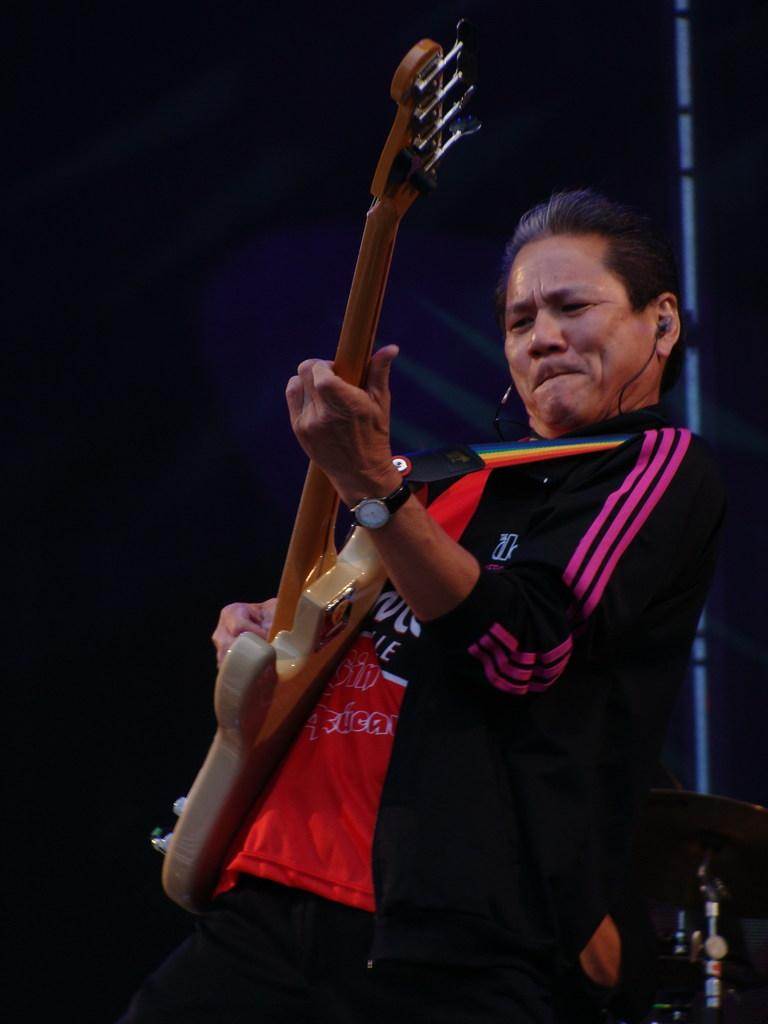What is the main subject of the image? There is a man in the image. What is the man doing in the image? The man is standing and playing a guitar. What is the man wearing in the image? The man is wearing a jacket. Can you describe the background of the image? The background of the image is blurred. What type of jam is the man eating in the image? There is no jam present in the image; the man is playing a guitar. Is the man sleeping in the image? No, the man is not sleeping in the image; he is standing and playing a guitar. 